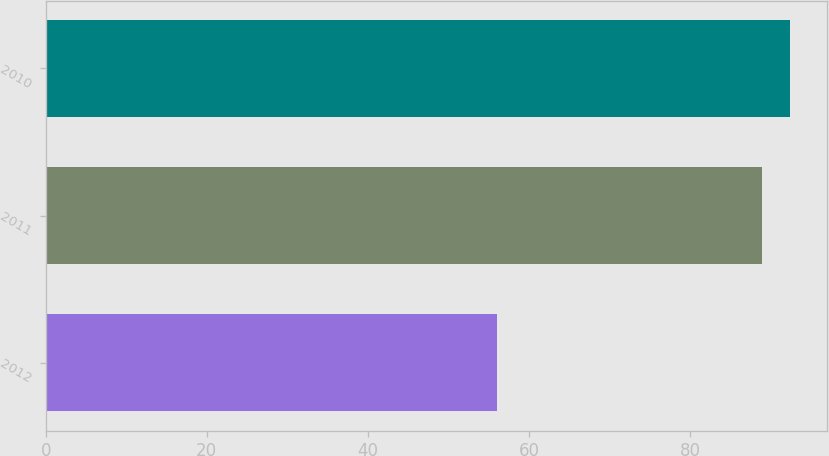<chart> <loc_0><loc_0><loc_500><loc_500><bar_chart><fcel>2012<fcel>2011<fcel>2010<nl><fcel>56<fcel>89<fcel>92.39<nl></chart> 